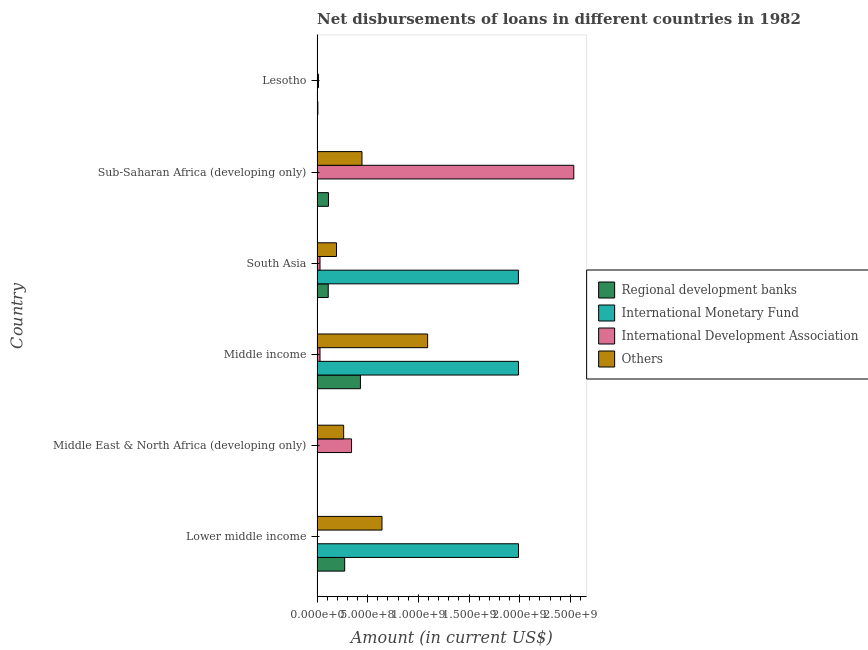Are the number of bars per tick equal to the number of legend labels?
Give a very brief answer. No. How many bars are there on the 2nd tick from the top?
Offer a terse response. 3. What is the label of the 2nd group of bars from the top?
Provide a short and direct response. Sub-Saharan Africa (developing only). In how many cases, is the number of bars for a given country not equal to the number of legend labels?
Offer a terse response. 4. What is the amount of loan disimbursed by regional development banks in Sub-Saharan Africa (developing only)?
Offer a very short reply. 1.12e+08. Across all countries, what is the maximum amount of loan disimbursed by regional development banks?
Make the answer very short. 4.28e+08. Across all countries, what is the minimum amount of loan disimbursed by international development association?
Offer a terse response. 0. In which country was the amount of loan disimbursed by international monetary fund maximum?
Your response must be concise. Lower middle income. What is the total amount of loan disimbursed by international monetary fund in the graph?
Make the answer very short. 5.96e+09. What is the difference between the amount of loan disimbursed by international development association in Middle East & North Africa (developing only) and that in Sub-Saharan Africa (developing only)?
Give a very brief answer. -2.19e+09. What is the difference between the amount of loan disimbursed by other organisations in Lower middle income and the amount of loan disimbursed by regional development banks in Middle East & North Africa (developing only)?
Provide a short and direct response. 6.39e+08. What is the average amount of loan disimbursed by other organisations per country?
Your answer should be compact. 4.39e+08. What is the difference between the amount of loan disimbursed by international development association and amount of loan disimbursed by other organisations in Sub-Saharan Africa (developing only)?
Your response must be concise. 2.09e+09. In how many countries, is the amount of loan disimbursed by other organisations greater than 1500000000 US$?
Keep it short and to the point. 0. What is the ratio of the amount of loan disimbursed by regional development banks in Middle income to that in South Asia?
Give a very brief answer. 3.88. Is the amount of loan disimbursed by other organisations in Lower middle income less than that in Middle income?
Your answer should be compact. Yes. Is the difference between the amount of loan disimbursed by international development association in Middle East & North Africa (developing only) and South Asia greater than the difference between the amount of loan disimbursed by regional development banks in Middle East & North Africa (developing only) and South Asia?
Your response must be concise. Yes. What is the difference between the highest and the second highest amount of loan disimbursed by international development association?
Offer a terse response. 2.19e+09. What is the difference between the highest and the lowest amount of loan disimbursed by regional development banks?
Your response must be concise. 4.26e+08. In how many countries, is the amount of loan disimbursed by international monetary fund greater than the average amount of loan disimbursed by international monetary fund taken over all countries?
Provide a succinct answer. 3. Is the sum of the amount of loan disimbursed by international development association in Middle income and Sub-Saharan Africa (developing only) greater than the maximum amount of loan disimbursed by regional development banks across all countries?
Ensure brevity in your answer.  Yes. Are all the bars in the graph horizontal?
Give a very brief answer. Yes. Are the values on the major ticks of X-axis written in scientific E-notation?
Your answer should be very brief. Yes. Does the graph contain grids?
Make the answer very short. No. Where does the legend appear in the graph?
Offer a very short reply. Center right. What is the title of the graph?
Offer a very short reply. Net disbursements of loans in different countries in 1982. Does "International Development Association" appear as one of the legend labels in the graph?
Ensure brevity in your answer.  Yes. What is the label or title of the X-axis?
Your answer should be very brief. Amount (in current US$). What is the Amount (in current US$) in Regional development banks in Lower middle income?
Your answer should be very brief. 2.73e+08. What is the Amount (in current US$) in International Monetary Fund in Lower middle income?
Give a very brief answer. 1.99e+09. What is the Amount (in current US$) in Others in Lower middle income?
Offer a terse response. 6.41e+08. What is the Amount (in current US$) of Regional development banks in Middle East & North Africa (developing only)?
Keep it short and to the point. 2.32e+06. What is the Amount (in current US$) in International Monetary Fund in Middle East & North Africa (developing only)?
Your answer should be compact. 0. What is the Amount (in current US$) of International Development Association in Middle East & North Africa (developing only)?
Make the answer very short. 3.40e+08. What is the Amount (in current US$) of Others in Middle East & North Africa (developing only)?
Offer a terse response. 2.63e+08. What is the Amount (in current US$) of Regional development banks in Middle income?
Provide a short and direct response. 4.28e+08. What is the Amount (in current US$) in International Monetary Fund in Middle income?
Give a very brief answer. 1.99e+09. What is the Amount (in current US$) in International Development Association in Middle income?
Keep it short and to the point. 2.91e+07. What is the Amount (in current US$) in Others in Middle income?
Offer a very short reply. 1.09e+09. What is the Amount (in current US$) of Regional development banks in South Asia?
Ensure brevity in your answer.  1.10e+08. What is the Amount (in current US$) of International Monetary Fund in South Asia?
Make the answer very short. 1.99e+09. What is the Amount (in current US$) of International Development Association in South Asia?
Keep it short and to the point. 2.91e+07. What is the Amount (in current US$) of Others in South Asia?
Provide a succinct answer. 1.92e+08. What is the Amount (in current US$) in Regional development banks in Sub-Saharan Africa (developing only)?
Your answer should be compact. 1.12e+08. What is the Amount (in current US$) of International Development Association in Sub-Saharan Africa (developing only)?
Keep it short and to the point. 2.53e+09. What is the Amount (in current US$) in Others in Sub-Saharan Africa (developing only)?
Your answer should be compact. 4.44e+08. What is the Amount (in current US$) in Regional development banks in Lesotho?
Provide a short and direct response. 7.96e+06. What is the Amount (in current US$) of International Monetary Fund in Lesotho?
Your answer should be very brief. 0. What is the Amount (in current US$) in International Development Association in Lesotho?
Ensure brevity in your answer.  1.41e+07. What is the Amount (in current US$) in Others in Lesotho?
Your answer should be very brief. 3.25e+06. Across all countries, what is the maximum Amount (in current US$) of Regional development banks?
Your response must be concise. 4.28e+08. Across all countries, what is the maximum Amount (in current US$) of International Monetary Fund?
Provide a succinct answer. 1.99e+09. Across all countries, what is the maximum Amount (in current US$) of International Development Association?
Give a very brief answer. 2.53e+09. Across all countries, what is the maximum Amount (in current US$) of Others?
Make the answer very short. 1.09e+09. Across all countries, what is the minimum Amount (in current US$) in Regional development banks?
Make the answer very short. 2.32e+06. Across all countries, what is the minimum Amount (in current US$) in International Monetary Fund?
Provide a short and direct response. 0. Across all countries, what is the minimum Amount (in current US$) of International Development Association?
Keep it short and to the point. 0. Across all countries, what is the minimum Amount (in current US$) in Others?
Make the answer very short. 3.25e+06. What is the total Amount (in current US$) of Regional development banks in the graph?
Provide a succinct answer. 9.34e+08. What is the total Amount (in current US$) in International Monetary Fund in the graph?
Provide a succinct answer. 5.96e+09. What is the total Amount (in current US$) of International Development Association in the graph?
Provide a short and direct response. 2.95e+09. What is the total Amount (in current US$) in Others in the graph?
Provide a short and direct response. 2.63e+09. What is the difference between the Amount (in current US$) of Regional development banks in Lower middle income and that in Middle East & North Africa (developing only)?
Offer a very short reply. 2.70e+08. What is the difference between the Amount (in current US$) of Others in Lower middle income and that in Middle East & North Africa (developing only)?
Your response must be concise. 3.79e+08. What is the difference between the Amount (in current US$) of Regional development banks in Lower middle income and that in Middle income?
Give a very brief answer. -1.55e+08. What is the difference between the Amount (in current US$) of Others in Lower middle income and that in Middle income?
Provide a succinct answer. -4.50e+08. What is the difference between the Amount (in current US$) in Regional development banks in Lower middle income and that in South Asia?
Make the answer very short. 1.62e+08. What is the difference between the Amount (in current US$) of International Monetary Fund in Lower middle income and that in South Asia?
Offer a terse response. 9.31e+05. What is the difference between the Amount (in current US$) of Others in Lower middle income and that in South Asia?
Ensure brevity in your answer.  4.49e+08. What is the difference between the Amount (in current US$) in Regional development banks in Lower middle income and that in Sub-Saharan Africa (developing only)?
Provide a succinct answer. 1.60e+08. What is the difference between the Amount (in current US$) in Others in Lower middle income and that in Sub-Saharan Africa (developing only)?
Keep it short and to the point. 1.98e+08. What is the difference between the Amount (in current US$) of Regional development banks in Lower middle income and that in Lesotho?
Provide a succinct answer. 2.65e+08. What is the difference between the Amount (in current US$) of Others in Lower middle income and that in Lesotho?
Provide a succinct answer. 6.38e+08. What is the difference between the Amount (in current US$) in Regional development banks in Middle East & North Africa (developing only) and that in Middle income?
Your answer should be compact. -4.26e+08. What is the difference between the Amount (in current US$) of International Development Association in Middle East & North Africa (developing only) and that in Middle income?
Your answer should be compact. 3.11e+08. What is the difference between the Amount (in current US$) of Others in Middle East & North Africa (developing only) and that in Middle income?
Your response must be concise. -8.29e+08. What is the difference between the Amount (in current US$) in Regional development banks in Middle East & North Africa (developing only) and that in South Asia?
Your response must be concise. -1.08e+08. What is the difference between the Amount (in current US$) in International Development Association in Middle East & North Africa (developing only) and that in South Asia?
Give a very brief answer. 3.11e+08. What is the difference between the Amount (in current US$) of Others in Middle East & North Africa (developing only) and that in South Asia?
Provide a succinct answer. 7.07e+07. What is the difference between the Amount (in current US$) of Regional development banks in Middle East & North Africa (developing only) and that in Sub-Saharan Africa (developing only)?
Your answer should be compact. -1.10e+08. What is the difference between the Amount (in current US$) of International Development Association in Middle East & North Africa (developing only) and that in Sub-Saharan Africa (developing only)?
Your answer should be very brief. -2.19e+09. What is the difference between the Amount (in current US$) in Others in Middle East & North Africa (developing only) and that in Sub-Saharan Africa (developing only)?
Ensure brevity in your answer.  -1.81e+08. What is the difference between the Amount (in current US$) of Regional development banks in Middle East & North Africa (developing only) and that in Lesotho?
Keep it short and to the point. -5.64e+06. What is the difference between the Amount (in current US$) in International Development Association in Middle East & North Africa (developing only) and that in Lesotho?
Your answer should be compact. 3.26e+08. What is the difference between the Amount (in current US$) in Others in Middle East & North Africa (developing only) and that in Lesotho?
Offer a very short reply. 2.59e+08. What is the difference between the Amount (in current US$) of Regional development banks in Middle income and that in South Asia?
Keep it short and to the point. 3.18e+08. What is the difference between the Amount (in current US$) in International Monetary Fund in Middle income and that in South Asia?
Provide a succinct answer. 9.31e+05. What is the difference between the Amount (in current US$) in Others in Middle income and that in South Asia?
Your answer should be very brief. 9.00e+08. What is the difference between the Amount (in current US$) of Regional development banks in Middle income and that in Sub-Saharan Africa (developing only)?
Offer a terse response. 3.16e+08. What is the difference between the Amount (in current US$) in International Development Association in Middle income and that in Sub-Saharan Africa (developing only)?
Ensure brevity in your answer.  -2.51e+09. What is the difference between the Amount (in current US$) in Others in Middle income and that in Sub-Saharan Africa (developing only)?
Offer a very short reply. 6.48e+08. What is the difference between the Amount (in current US$) of Regional development banks in Middle income and that in Lesotho?
Give a very brief answer. 4.20e+08. What is the difference between the Amount (in current US$) of International Development Association in Middle income and that in Lesotho?
Your answer should be compact. 1.50e+07. What is the difference between the Amount (in current US$) of Others in Middle income and that in Lesotho?
Offer a very short reply. 1.09e+09. What is the difference between the Amount (in current US$) in Regional development banks in South Asia and that in Sub-Saharan Africa (developing only)?
Keep it short and to the point. -2.15e+06. What is the difference between the Amount (in current US$) of International Development Association in South Asia and that in Sub-Saharan Africa (developing only)?
Offer a terse response. -2.51e+09. What is the difference between the Amount (in current US$) in Others in South Asia and that in Sub-Saharan Africa (developing only)?
Keep it short and to the point. -2.52e+08. What is the difference between the Amount (in current US$) of Regional development banks in South Asia and that in Lesotho?
Ensure brevity in your answer.  1.02e+08. What is the difference between the Amount (in current US$) in International Development Association in South Asia and that in Lesotho?
Make the answer very short. 1.50e+07. What is the difference between the Amount (in current US$) of Others in South Asia and that in Lesotho?
Offer a very short reply. 1.89e+08. What is the difference between the Amount (in current US$) in Regional development banks in Sub-Saharan Africa (developing only) and that in Lesotho?
Give a very brief answer. 1.05e+08. What is the difference between the Amount (in current US$) of International Development Association in Sub-Saharan Africa (developing only) and that in Lesotho?
Your answer should be very brief. 2.52e+09. What is the difference between the Amount (in current US$) of Others in Sub-Saharan Africa (developing only) and that in Lesotho?
Your answer should be compact. 4.40e+08. What is the difference between the Amount (in current US$) in Regional development banks in Lower middle income and the Amount (in current US$) in International Development Association in Middle East & North Africa (developing only)?
Provide a succinct answer. -6.76e+07. What is the difference between the Amount (in current US$) of Regional development banks in Lower middle income and the Amount (in current US$) of Others in Middle East & North Africa (developing only)?
Make the answer very short. 1.01e+07. What is the difference between the Amount (in current US$) in International Monetary Fund in Lower middle income and the Amount (in current US$) in International Development Association in Middle East & North Africa (developing only)?
Offer a terse response. 1.65e+09. What is the difference between the Amount (in current US$) of International Monetary Fund in Lower middle income and the Amount (in current US$) of Others in Middle East & North Africa (developing only)?
Provide a succinct answer. 1.73e+09. What is the difference between the Amount (in current US$) in Regional development banks in Lower middle income and the Amount (in current US$) in International Monetary Fund in Middle income?
Provide a short and direct response. -1.72e+09. What is the difference between the Amount (in current US$) of Regional development banks in Lower middle income and the Amount (in current US$) of International Development Association in Middle income?
Ensure brevity in your answer.  2.44e+08. What is the difference between the Amount (in current US$) of Regional development banks in Lower middle income and the Amount (in current US$) of Others in Middle income?
Make the answer very short. -8.19e+08. What is the difference between the Amount (in current US$) of International Monetary Fund in Lower middle income and the Amount (in current US$) of International Development Association in Middle income?
Provide a succinct answer. 1.96e+09. What is the difference between the Amount (in current US$) of International Monetary Fund in Lower middle income and the Amount (in current US$) of Others in Middle income?
Offer a terse response. 8.97e+08. What is the difference between the Amount (in current US$) of Regional development banks in Lower middle income and the Amount (in current US$) of International Monetary Fund in South Asia?
Keep it short and to the point. -1.71e+09. What is the difference between the Amount (in current US$) in Regional development banks in Lower middle income and the Amount (in current US$) in International Development Association in South Asia?
Make the answer very short. 2.44e+08. What is the difference between the Amount (in current US$) in Regional development banks in Lower middle income and the Amount (in current US$) in Others in South Asia?
Provide a succinct answer. 8.08e+07. What is the difference between the Amount (in current US$) in International Monetary Fund in Lower middle income and the Amount (in current US$) in International Development Association in South Asia?
Offer a terse response. 1.96e+09. What is the difference between the Amount (in current US$) of International Monetary Fund in Lower middle income and the Amount (in current US$) of Others in South Asia?
Your answer should be very brief. 1.80e+09. What is the difference between the Amount (in current US$) in Regional development banks in Lower middle income and the Amount (in current US$) in International Development Association in Sub-Saharan Africa (developing only)?
Your response must be concise. -2.26e+09. What is the difference between the Amount (in current US$) in Regional development banks in Lower middle income and the Amount (in current US$) in Others in Sub-Saharan Africa (developing only)?
Offer a very short reply. -1.71e+08. What is the difference between the Amount (in current US$) of International Monetary Fund in Lower middle income and the Amount (in current US$) of International Development Association in Sub-Saharan Africa (developing only)?
Your answer should be compact. -5.46e+08. What is the difference between the Amount (in current US$) of International Monetary Fund in Lower middle income and the Amount (in current US$) of Others in Sub-Saharan Africa (developing only)?
Your answer should be very brief. 1.54e+09. What is the difference between the Amount (in current US$) in Regional development banks in Lower middle income and the Amount (in current US$) in International Development Association in Lesotho?
Your answer should be very brief. 2.59e+08. What is the difference between the Amount (in current US$) in Regional development banks in Lower middle income and the Amount (in current US$) in Others in Lesotho?
Offer a very short reply. 2.69e+08. What is the difference between the Amount (in current US$) in International Monetary Fund in Lower middle income and the Amount (in current US$) in International Development Association in Lesotho?
Keep it short and to the point. 1.97e+09. What is the difference between the Amount (in current US$) in International Monetary Fund in Lower middle income and the Amount (in current US$) in Others in Lesotho?
Provide a succinct answer. 1.99e+09. What is the difference between the Amount (in current US$) of Regional development banks in Middle East & North Africa (developing only) and the Amount (in current US$) of International Monetary Fund in Middle income?
Offer a terse response. -1.99e+09. What is the difference between the Amount (in current US$) in Regional development banks in Middle East & North Africa (developing only) and the Amount (in current US$) in International Development Association in Middle income?
Your answer should be very brief. -2.68e+07. What is the difference between the Amount (in current US$) of Regional development banks in Middle East & North Africa (developing only) and the Amount (in current US$) of Others in Middle income?
Offer a terse response. -1.09e+09. What is the difference between the Amount (in current US$) in International Development Association in Middle East & North Africa (developing only) and the Amount (in current US$) in Others in Middle income?
Offer a terse response. -7.51e+08. What is the difference between the Amount (in current US$) in Regional development banks in Middle East & North Africa (developing only) and the Amount (in current US$) in International Monetary Fund in South Asia?
Your answer should be very brief. -1.99e+09. What is the difference between the Amount (in current US$) of Regional development banks in Middle East & North Africa (developing only) and the Amount (in current US$) of International Development Association in South Asia?
Keep it short and to the point. -2.68e+07. What is the difference between the Amount (in current US$) of Regional development banks in Middle East & North Africa (developing only) and the Amount (in current US$) of Others in South Asia?
Give a very brief answer. -1.90e+08. What is the difference between the Amount (in current US$) of International Development Association in Middle East & North Africa (developing only) and the Amount (in current US$) of Others in South Asia?
Your response must be concise. 1.48e+08. What is the difference between the Amount (in current US$) of Regional development banks in Middle East & North Africa (developing only) and the Amount (in current US$) of International Development Association in Sub-Saharan Africa (developing only)?
Keep it short and to the point. -2.53e+09. What is the difference between the Amount (in current US$) in Regional development banks in Middle East & North Africa (developing only) and the Amount (in current US$) in Others in Sub-Saharan Africa (developing only)?
Your answer should be very brief. -4.41e+08. What is the difference between the Amount (in current US$) of International Development Association in Middle East & North Africa (developing only) and the Amount (in current US$) of Others in Sub-Saharan Africa (developing only)?
Provide a succinct answer. -1.03e+08. What is the difference between the Amount (in current US$) in Regional development banks in Middle East & North Africa (developing only) and the Amount (in current US$) in International Development Association in Lesotho?
Your response must be concise. -1.18e+07. What is the difference between the Amount (in current US$) in Regional development banks in Middle East & North Africa (developing only) and the Amount (in current US$) in Others in Lesotho?
Make the answer very short. -9.31e+05. What is the difference between the Amount (in current US$) in International Development Association in Middle East & North Africa (developing only) and the Amount (in current US$) in Others in Lesotho?
Make the answer very short. 3.37e+08. What is the difference between the Amount (in current US$) of Regional development banks in Middle income and the Amount (in current US$) of International Monetary Fund in South Asia?
Your answer should be compact. -1.56e+09. What is the difference between the Amount (in current US$) of Regional development banks in Middle income and the Amount (in current US$) of International Development Association in South Asia?
Keep it short and to the point. 3.99e+08. What is the difference between the Amount (in current US$) of Regional development banks in Middle income and the Amount (in current US$) of Others in South Asia?
Make the answer very short. 2.36e+08. What is the difference between the Amount (in current US$) of International Monetary Fund in Middle income and the Amount (in current US$) of International Development Association in South Asia?
Offer a terse response. 1.96e+09. What is the difference between the Amount (in current US$) in International Monetary Fund in Middle income and the Amount (in current US$) in Others in South Asia?
Provide a succinct answer. 1.80e+09. What is the difference between the Amount (in current US$) of International Development Association in Middle income and the Amount (in current US$) of Others in South Asia?
Keep it short and to the point. -1.63e+08. What is the difference between the Amount (in current US$) of Regional development banks in Middle income and the Amount (in current US$) of International Development Association in Sub-Saharan Africa (developing only)?
Provide a succinct answer. -2.11e+09. What is the difference between the Amount (in current US$) in Regional development banks in Middle income and the Amount (in current US$) in Others in Sub-Saharan Africa (developing only)?
Your answer should be compact. -1.55e+07. What is the difference between the Amount (in current US$) in International Monetary Fund in Middle income and the Amount (in current US$) in International Development Association in Sub-Saharan Africa (developing only)?
Keep it short and to the point. -5.46e+08. What is the difference between the Amount (in current US$) in International Monetary Fund in Middle income and the Amount (in current US$) in Others in Sub-Saharan Africa (developing only)?
Your answer should be very brief. 1.54e+09. What is the difference between the Amount (in current US$) of International Development Association in Middle income and the Amount (in current US$) of Others in Sub-Saharan Africa (developing only)?
Keep it short and to the point. -4.14e+08. What is the difference between the Amount (in current US$) of Regional development banks in Middle income and the Amount (in current US$) of International Development Association in Lesotho?
Your answer should be compact. 4.14e+08. What is the difference between the Amount (in current US$) of Regional development banks in Middle income and the Amount (in current US$) of Others in Lesotho?
Ensure brevity in your answer.  4.25e+08. What is the difference between the Amount (in current US$) of International Monetary Fund in Middle income and the Amount (in current US$) of International Development Association in Lesotho?
Provide a succinct answer. 1.97e+09. What is the difference between the Amount (in current US$) of International Monetary Fund in Middle income and the Amount (in current US$) of Others in Lesotho?
Offer a very short reply. 1.99e+09. What is the difference between the Amount (in current US$) in International Development Association in Middle income and the Amount (in current US$) in Others in Lesotho?
Offer a terse response. 2.59e+07. What is the difference between the Amount (in current US$) in Regional development banks in South Asia and the Amount (in current US$) in International Development Association in Sub-Saharan Africa (developing only)?
Ensure brevity in your answer.  -2.42e+09. What is the difference between the Amount (in current US$) of Regional development banks in South Asia and the Amount (in current US$) of Others in Sub-Saharan Africa (developing only)?
Give a very brief answer. -3.33e+08. What is the difference between the Amount (in current US$) of International Monetary Fund in South Asia and the Amount (in current US$) of International Development Association in Sub-Saharan Africa (developing only)?
Provide a short and direct response. -5.47e+08. What is the difference between the Amount (in current US$) of International Monetary Fund in South Asia and the Amount (in current US$) of Others in Sub-Saharan Africa (developing only)?
Give a very brief answer. 1.54e+09. What is the difference between the Amount (in current US$) in International Development Association in South Asia and the Amount (in current US$) in Others in Sub-Saharan Africa (developing only)?
Provide a short and direct response. -4.14e+08. What is the difference between the Amount (in current US$) in Regional development banks in South Asia and the Amount (in current US$) in International Development Association in Lesotho?
Make the answer very short. 9.62e+07. What is the difference between the Amount (in current US$) in Regional development banks in South Asia and the Amount (in current US$) in Others in Lesotho?
Your answer should be compact. 1.07e+08. What is the difference between the Amount (in current US$) in International Monetary Fund in South Asia and the Amount (in current US$) in International Development Association in Lesotho?
Your answer should be compact. 1.97e+09. What is the difference between the Amount (in current US$) of International Monetary Fund in South Asia and the Amount (in current US$) of Others in Lesotho?
Your answer should be very brief. 1.98e+09. What is the difference between the Amount (in current US$) in International Development Association in South Asia and the Amount (in current US$) in Others in Lesotho?
Offer a terse response. 2.59e+07. What is the difference between the Amount (in current US$) of Regional development banks in Sub-Saharan Africa (developing only) and the Amount (in current US$) of International Development Association in Lesotho?
Your answer should be very brief. 9.84e+07. What is the difference between the Amount (in current US$) of Regional development banks in Sub-Saharan Africa (developing only) and the Amount (in current US$) of Others in Lesotho?
Keep it short and to the point. 1.09e+08. What is the difference between the Amount (in current US$) in International Development Association in Sub-Saharan Africa (developing only) and the Amount (in current US$) in Others in Lesotho?
Make the answer very short. 2.53e+09. What is the average Amount (in current US$) in Regional development banks per country?
Provide a succinct answer. 1.56e+08. What is the average Amount (in current US$) in International Monetary Fund per country?
Make the answer very short. 9.94e+08. What is the average Amount (in current US$) of International Development Association per country?
Make the answer very short. 4.91e+08. What is the average Amount (in current US$) of Others per country?
Your answer should be compact. 4.39e+08. What is the difference between the Amount (in current US$) of Regional development banks and Amount (in current US$) of International Monetary Fund in Lower middle income?
Give a very brief answer. -1.72e+09. What is the difference between the Amount (in current US$) of Regional development banks and Amount (in current US$) of Others in Lower middle income?
Make the answer very short. -3.68e+08. What is the difference between the Amount (in current US$) of International Monetary Fund and Amount (in current US$) of Others in Lower middle income?
Offer a terse response. 1.35e+09. What is the difference between the Amount (in current US$) in Regional development banks and Amount (in current US$) in International Development Association in Middle East & North Africa (developing only)?
Keep it short and to the point. -3.38e+08. What is the difference between the Amount (in current US$) of Regional development banks and Amount (in current US$) of Others in Middle East & North Africa (developing only)?
Give a very brief answer. -2.60e+08. What is the difference between the Amount (in current US$) of International Development Association and Amount (in current US$) of Others in Middle East & North Africa (developing only)?
Give a very brief answer. 7.77e+07. What is the difference between the Amount (in current US$) of Regional development banks and Amount (in current US$) of International Monetary Fund in Middle income?
Provide a succinct answer. -1.56e+09. What is the difference between the Amount (in current US$) in Regional development banks and Amount (in current US$) in International Development Association in Middle income?
Give a very brief answer. 3.99e+08. What is the difference between the Amount (in current US$) of Regional development banks and Amount (in current US$) of Others in Middle income?
Offer a very short reply. -6.64e+08. What is the difference between the Amount (in current US$) of International Monetary Fund and Amount (in current US$) of International Development Association in Middle income?
Give a very brief answer. 1.96e+09. What is the difference between the Amount (in current US$) of International Monetary Fund and Amount (in current US$) of Others in Middle income?
Ensure brevity in your answer.  8.97e+08. What is the difference between the Amount (in current US$) in International Development Association and Amount (in current US$) in Others in Middle income?
Your answer should be compact. -1.06e+09. What is the difference between the Amount (in current US$) in Regional development banks and Amount (in current US$) in International Monetary Fund in South Asia?
Offer a very short reply. -1.88e+09. What is the difference between the Amount (in current US$) of Regional development banks and Amount (in current US$) of International Development Association in South Asia?
Provide a succinct answer. 8.12e+07. What is the difference between the Amount (in current US$) of Regional development banks and Amount (in current US$) of Others in South Asia?
Provide a succinct answer. -8.16e+07. What is the difference between the Amount (in current US$) of International Monetary Fund and Amount (in current US$) of International Development Association in South Asia?
Give a very brief answer. 1.96e+09. What is the difference between the Amount (in current US$) in International Monetary Fund and Amount (in current US$) in Others in South Asia?
Your answer should be compact. 1.80e+09. What is the difference between the Amount (in current US$) of International Development Association and Amount (in current US$) of Others in South Asia?
Your answer should be very brief. -1.63e+08. What is the difference between the Amount (in current US$) in Regional development banks and Amount (in current US$) in International Development Association in Sub-Saharan Africa (developing only)?
Provide a short and direct response. -2.42e+09. What is the difference between the Amount (in current US$) in Regional development banks and Amount (in current US$) in Others in Sub-Saharan Africa (developing only)?
Your response must be concise. -3.31e+08. What is the difference between the Amount (in current US$) of International Development Association and Amount (in current US$) of Others in Sub-Saharan Africa (developing only)?
Provide a succinct answer. 2.09e+09. What is the difference between the Amount (in current US$) of Regional development banks and Amount (in current US$) of International Development Association in Lesotho?
Your answer should be compact. -6.13e+06. What is the difference between the Amount (in current US$) in Regional development banks and Amount (in current US$) in Others in Lesotho?
Provide a short and direct response. 4.71e+06. What is the difference between the Amount (in current US$) of International Development Association and Amount (in current US$) of Others in Lesotho?
Provide a short and direct response. 1.08e+07. What is the ratio of the Amount (in current US$) of Regional development banks in Lower middle income to that in Middle East & North Africa (developing only)?
Give a very brief answer. 117.65. What is the ratio of the Amount (in current US$) of Others in Lower middle income to that in Middle East & North Africa (developing only)?
Your answer should be very brief. 2.44. What is the ratio of the Amount (in current US$) in Regional development banks in Lower middle income to that in Middle income?
Ensure brevity in your answer.  0.64. What is the ratio of the Amount (in current US$) in International Monetary Fund in Lower middle income to that in Middle income?
Your answer should be very brief. 1. What is the ratio of the Amount (in current US$) in Others in Lower middle income to that in Middle income?
Provide a short and direct response. 0.59. What is the ratio of the Amount (in current US$) of Regional development banks in Lower middle income to that in South Asia?
Your response must be concise. 2.47. What is the ratio of the Amount (in current US$) of Others in Lower middle income to that in South Asia?
Provide a succinct answer. 3.34. What is the ratio of the Amount (in current US$) in Regional development banks in Lower middle income to that in Sub-Saharan Africa (developing only)?
Your response must be concise. 2.42. What is the ratio of the Amount (in current US$) of Others in Lower middle income to that in Sub-Saharan Africa (developing only)?
Your answer should be very brief. 1.45. What is the ratio of the Amount (in current US$) in Regional development banks in Lower middle income to that in Lesotho?
Provide a short and direct response. 34.27. What is the ratio of the Amount (in current US$) in Others in Lower middle income to that in Lesotho?
Your answer should be very brief. 197.34. What is the ratio of the Amount (in current US$) of Regional development banks in Middle East & North Africa (developing only) to that in Middle income?
Provide a short and direct response. 0.01. What is the ratio of the Amount (in current US$) of International Development Association in Middle East & North Africa (developing only) to that in Middle income?
Keep it short and to the point. 11.69. What is the ratio of the Amount (in current US$) of Others in Middle East & North Africa (developing only) to that in Middle income?
Provide a succinct answer. 0.24. What is the ratio of the Amount (in current US$) in Regional development banks in Middle East & North Africa (developing only) to that in South Asia?
Ensure brevity in your answer.  0.02. What is the ratio of the Amount (in current US$) in International Development Association in Middle East & North Africa (developing only) to that in South Asia?
Offer a very short reply. 11.69. What is the ratio of the Amount (in current US$) of Others in Middle East & North Africa (developing only) to that in South Asia?
Keep it short and to the point. 1.37. What is the ratio of the Amount (in current US$) of Regional development banks in Middle East & North Africa (developing only) to that in Sub-Saharan Africa (developing only)?
Ensure brevity in your answer.  0.02. What is the ratio of the Amount (in current US$) of International Development Association in Middle East & North Africa (developing only) to that in Sub-Saharan Africa (developing only)?
Give a very brief answer. 0.13. What is the ratio of the Amount (in current US$) in Others in Middle East & North Africa (developing only) to that in Sub-Saharan Africa (developing only)?
Provide a succinct answer. 0.59. What is the ratio of the Amount (in current US$) of Regional development banks in Middle East & North Africa (developing only) to that in Lesotho?
Ensure brevity in your answer.  0.29. What is the ratio of the Amount (in current US$) of International Development Association in Middle East & North Africa (developing only) to that in Lesotho?
Give a very brief answer. 24.15. What is the ratio of the Amount (in current US$) of Others in Middle East & North Africa (developing only) to that in Lesotho?
Keep it short and to the point. 80.83. What is the ratio of the Amount (in current US$) in Regional development banks in Middle income to that in South Asia?
Your answer should be very brief. 3.88. What is the ratio of the Amount (in current US$) of International Monetary Fund in Middle income to that in South Asia?
Make the answer very short. 1. What is the ratio of the Amount (in current US$) in International Development Association in Middle income to that in South Asia?
Your answer should be very brief. 1. What is the ratio of the Amount (in current US$) in Others in Middle income to that in South Asia?
Ensure brevity in your answer.  5.69. What is the ratio of the Amount (in current US$) in Regional development banks in Middle income to that in Sub-Saharan Africa (developing only)?
Offer a very short reply. 3.81. What is the ratio of the Amount (in current US$) of International Development Association in Middle income to that in Sub-Saharan Africa (developing only)?
Provide a short and direct response. 0.01. What is the ratio of the Amount (in current US$) of Others in Middle income to that in Sub-Saharan Africa (developing only)?
Offer a very short reply. 2.46. What is the ratio of the Amount (in current US$) in Regional development banks in Middle income to that in Lesotho?
Provide a succinct answer. 53.8. What is the ratio of the Amount (in current US$) in International Development Association in Middle income to that in Lesotho?
Make the answer very short. 2.07. What is the ratio of the Amount (in current US$) in Others in Middle income to that in Lesotho?
Keep it short and to the point. 335.98. What is the ratio of the Amount (in current US$) in Regional development banks in South Asia to that in Sub-Saharan Africa (developing only)?
Provide a succinct answer. 0.98. What is the ratio of the Amount (in current US$) in International Development Association in South Asia to that in Sub-Saharan Africa (developing only)?
Offer a terse response. 0.01. What is the ratio of the Amount (in current US$) in Others in South Asia to that in Sub-Saharan Africa (developing only)?
Make the answer very short. 0.43. What is the ratio of the Amount (in current US$) of Regional development banks in South Asia to that in Lesotho?
Your answer should be compact. 13.87. What is the ratio of the Amount (in current US$) of International Development Association in South Asia to that in Lesotho?
Your answer should be very brief. 2.07. What is the ratio of the Amount (in current US$) in Others in South Asia to that in Lesotho?
Your response must be concise. 59.07. What is the ratio of the Amount (in current US$) of Regional development banks in Sub-Saharan Africa (developing only) to that in Lesotho?
Your answer should be very brief. 14.14. What is the ratio of the Amount (in current US$) of International Development Association in Sub-Saharan Africa (developing only) to that in Lesotho?
Your response must be concise. 179.85. What is the ratio of the Amount (in current US$) in Others in Sub-Saharan Africa (developing only) to that in Lesotho?
Ensure brevity in your answer.  136.53. What is the difference between the highest and the second highest Amount (in current US$) of Regional development banks?
Provide a short and direct response. 1.55e+08. What is the difference between the highest and the second highest Amount (in current US$) of International Development Association?
Make the answer very short. 2.19e+09. What is the difference between the highest and the second highest Amount (in current US$) of Others?
Your answer should be very brief. 4.50e+08. What is the difference between the highest and the lowest Amount (in current US$) in Regional development banks?
Your answer should be very brief. 4.26e+08. What is the difference between the highest and the lowest Amount (in current US$) in International Monetary Fund?
Ensure brevity in your answer.  1.99e+09. What is the difference between the highest and the lowest Amount (in current US$) in International Development Association?
Your response must be concise. 2.53e+09. What is the difference between the highest and the lowest Amount (in current US$) in Others?
Give a very brief answer. 1.09e+09. 